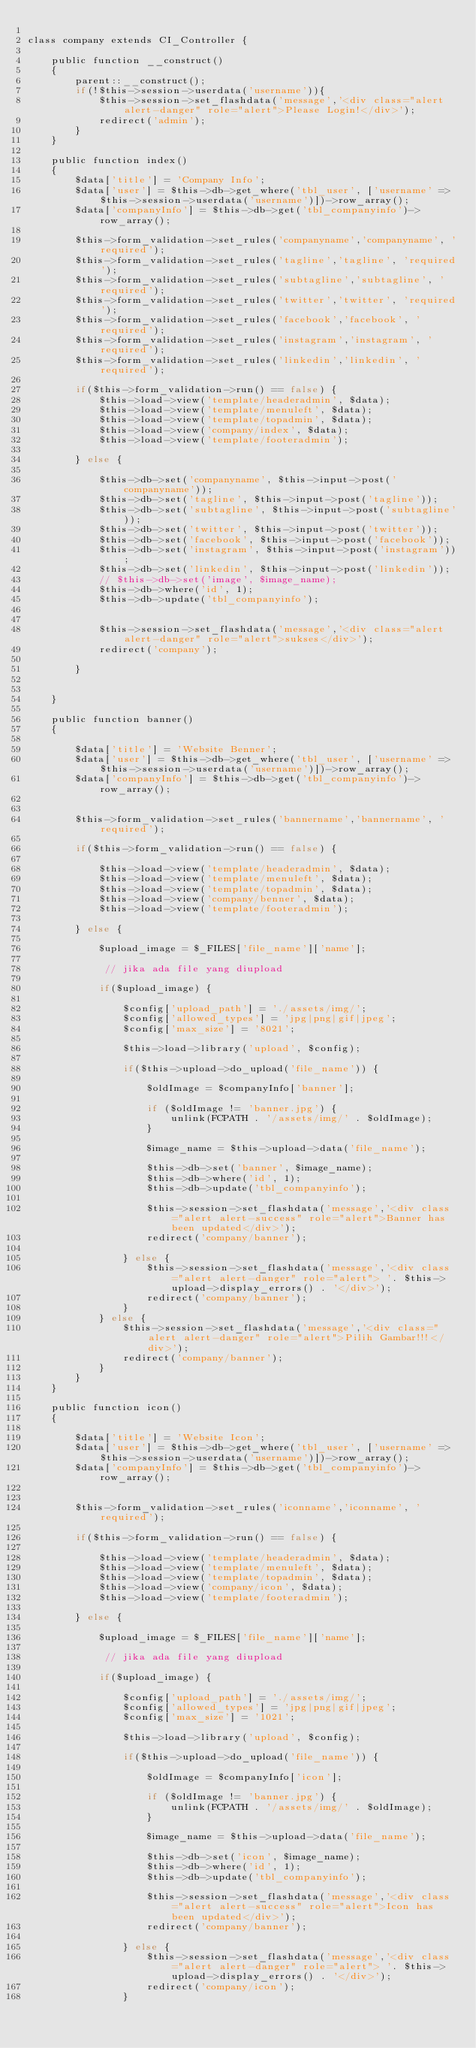Convert code to text. <code><loc_0><loc_0><loc_500><loc_500><_PHP_>
class company extends CI_Controller {

	public function __construct()
	{
		parent::__construct();
		if(!$this->session->userdata('username')){
			$this->session->set_flashdata('message','<div class="alert alert-danger" role="alert">Please Login!</div>');
			redirect('admin');
		}
	}

	public function index()
	{
		$data['title'] = 'Company Info';
		$data['user'] = $this->db->get_where('tbl_user', ['username' => $this->session->userdata('username')])->row_array();
		$data['companyInfo'] = $this->db->get('tbl_companyinfo')->row_array();

		$this->form_validation->set_rules('companyname','companyname', 'required');
		$this->form_validation->set_rules('tagline','tagline', 'required');
		$this->form_validation->set_rules('subtagline','subtagline', 'required');
		$this->form_validation->set_rules('twitter','twitter', 'required');
		$this->form_validation->set_rules('facebook','facebook', 'required');
		$this->form_validation->set_rules('instagram','instagram', 'required');
		$this->form_validation->set_rules('linkedin','linkedin', 'required');

		if($this->form_validation->run() == false) {
			$this->load->view('template/headeradmin', $data);
			$this->load->view('template/menuleft', $data);
			$this->load->view('template/topadmin', $data);
			$this->load->view('company/index', $data);
			$this->load->view('template/footeradmin');

		} else {

			$this->db->set('companyname', $this->input->post('companyname'));
			$this->db->set('tagline', $this->input->post('tagline'));
			$this->db->set('subtagline', $this->input->post('subtagline'));
			$this->db->set('twitter', $this->input->post('twitter'));
			$this->db->set('facebook', $this->input->post('facebook'));
			$this->db->set('instagram', $this->input->post('instagram'));
			$this->db->set('linkedin', $this->input->post('linkedin'));
			// $this->db->set('image', $image_name);
			$this->db->where('id', 1); 
			$this->db->update('tbl_companyinfo');


			$this->session->set_flashdata('message','<div class="alert alert-danger" role="alert">sukses</div>');
			redirect('company');
					
		}

		
	}		

	public function banner() 
	{
		
		$data['title'] = 'Website Benner';
		$data['user'] = $this->db->get_where('tbl_user', ['username' => $this->session->userdata('username')])->row_array();
		$data['companyInfo'] = $this->db->get('tbl_companyinfo')->row_array();


		$this->form_validation->set_rules('bannername','bannername', 'required');

		if($this->form_validation->run() == false) {

			$this->load->view('template/headeradmin', $data);
			$this->load->view('template/menuleft', $data);
			$this->load->view('template/topadmin', $data);
			$this->load->view('company/benner', $data);
			$this->load->view('template/footeradmin');
		
		} else {

			$upload_image = $_FILES['file_name']['name'];

			 // jika ada file yang diupload 

			if($upload_image) {
				
				$config['upload_path'] = './assets/img/';
				$config['allowed_types'] = 'jpg|png|gif|jpeg';
				$config['max_size'] = '8021';

				$this->load->library('upload', $config);

				if($this->upload->do_upload('file_name')) {
					
					$oldImage = $companyInfo['banner'];

					if ($oldImage != 'banner.jpg') {
						unlink(FCPATH . '/assets/img/' . $oldImage);
					}

					$image_name = $this->upload->data('file_name');
					
					$this->db->set('banner', $image_name);
					$this->db->where('id', 1); 
					$this->db->update('tbl_companyinfo');

					$this->session->set_flashdata('message','<div class="alert alert-success" role="alert">Banner has been updated</div>');
					redirect('company/banner');

				} else {
					$this->session->set_flashdata('message','<div class="alert alert-danger" role="alert"> '. $this->upload->display_errors() . '</div>');
					redirect('company/banner');
				}
			} else {
				$this->session->set_flashdata('message','<div class="alert alert-danger" role="alert">Pilih Gambar!!!</div>');
				redirect('company/banner');
			}
		}			
	}

	public function icon() 
	{
		
		$data['title'] = 'Website Icon';
		$data['user'] = $this->db->get_where('tbl_user', ['username' => $this->session->userdata('username')])->row_array();
		$data['companyInfo'] = $this->db->get('tbl_companyinfo')->row_array();


		$this->form_validation->set_rules('iconname','iconname', 'required');

		if($this->form_validation->run() == false) {

			$this->load->view('template/headeradmin', $data);
			$this->load->view('template/menuleft', $data);
			$this->load->view('template/topadmin', $data);
			$this->load->view('company/icon', $data);
			$this->load->view('template/footeradmin');
		
		} else {

			$upload_image = $_FILES['file_name']['name'];

			 // jika ada file yang diupload 

			if($upload_image) {
				
				$config['upload_path'] = './assets/img/';
				$config['allowed_types'] = 'jpg|png|gif|jpeg';
				$config['max_size'] = '1021';

				$this->load->library('upload', $config);

				if($this->upload->do_upload('file_name')) {
					
					$oldImage = $companyInfo['icon'];

					if ($oldImage != 'banner.jpg') {
						unlink(FCPATH . '/assets/img/' . $oldImage);
					}

					$image_name = $this->upload->data('file_name');
					
					$this->db->set('icon', $image_name);
					$this->db->where('id', 1); 
					$this->db->update('tbl_companyinfo');

					$this->session->set_flashdata('message','<div class="alert alert-success" role="alert">Icon has been updated</div>');
					redirect('company/banner');

				} else {
					$this->session->set_flashdata('message','<div class="alert alert-danger" role="alert"> '. $this->upload->display_errors() . '</div>');
					redirect('company/icon');
				}</code> 